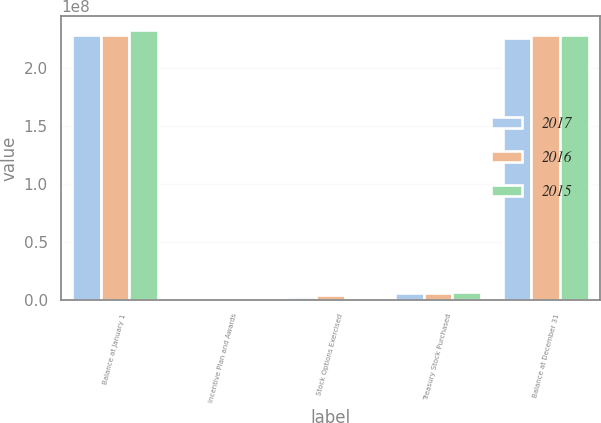Convert chart to OTSL. <chart><loc_0><loc_0><loc_500><loc_500><stacked_bar_chart><ecel><fcel>Balance at January 1<fcel>Incentive Plan and Awards<fcel>Stock Options Exercised<fcel>Treasury Stock Purchased<fcel>Balance at December 31<nl><fcel>2017<fcel>2.28605e+08<fcel>1.32013e+06<fcel>1.99736e+06<fcel>5.7963e+06<fcel>2.26127e+08<nl><fcel>2016<fcel>2.29294e+08<fcel>1.20912e+06<fcel>4.15673e+06<fcel>6.05415e+06<fcel>2.28605e+08<nl><fcel>2015<fcel>2.33391e+08<fcel>1.03366e+06<fcel>1.72128e+06<fcel>6.85187e+06<fcel>2.29294e+08<nl></chart> 